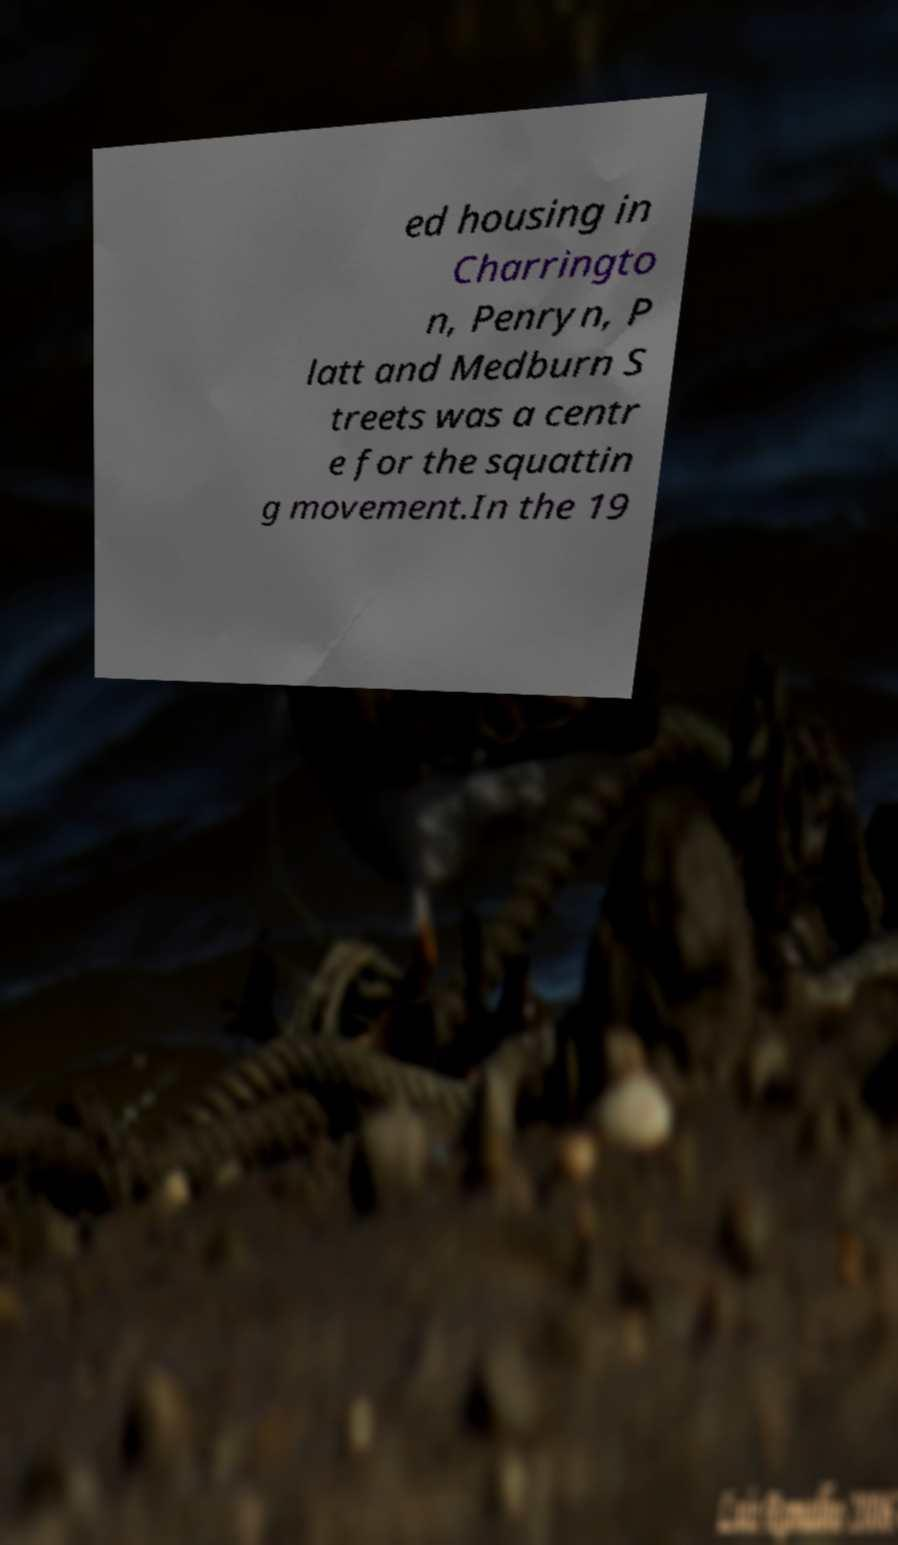I need the written content from this picture converted into text. Can you do that? ed housing in Charringto n, Penryn, P latt and Medburn S treets was a centr e for the squattin g movement.In the 19 